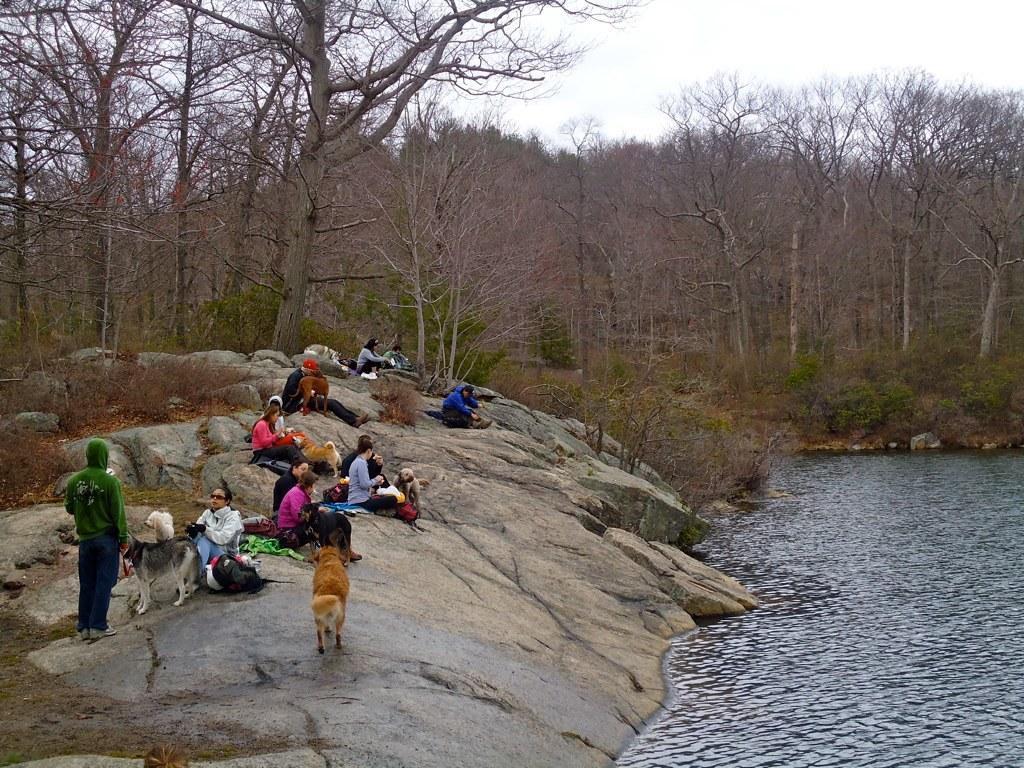In one or two sentences, can you explain what this image depicts? This picture is clicked outside the city. On the right there is a water body. On the left we can see the group of persons seems to be sitting on the rock and there are some animals and a person standing on the rock. In the background there is a sky, trees and plants. 